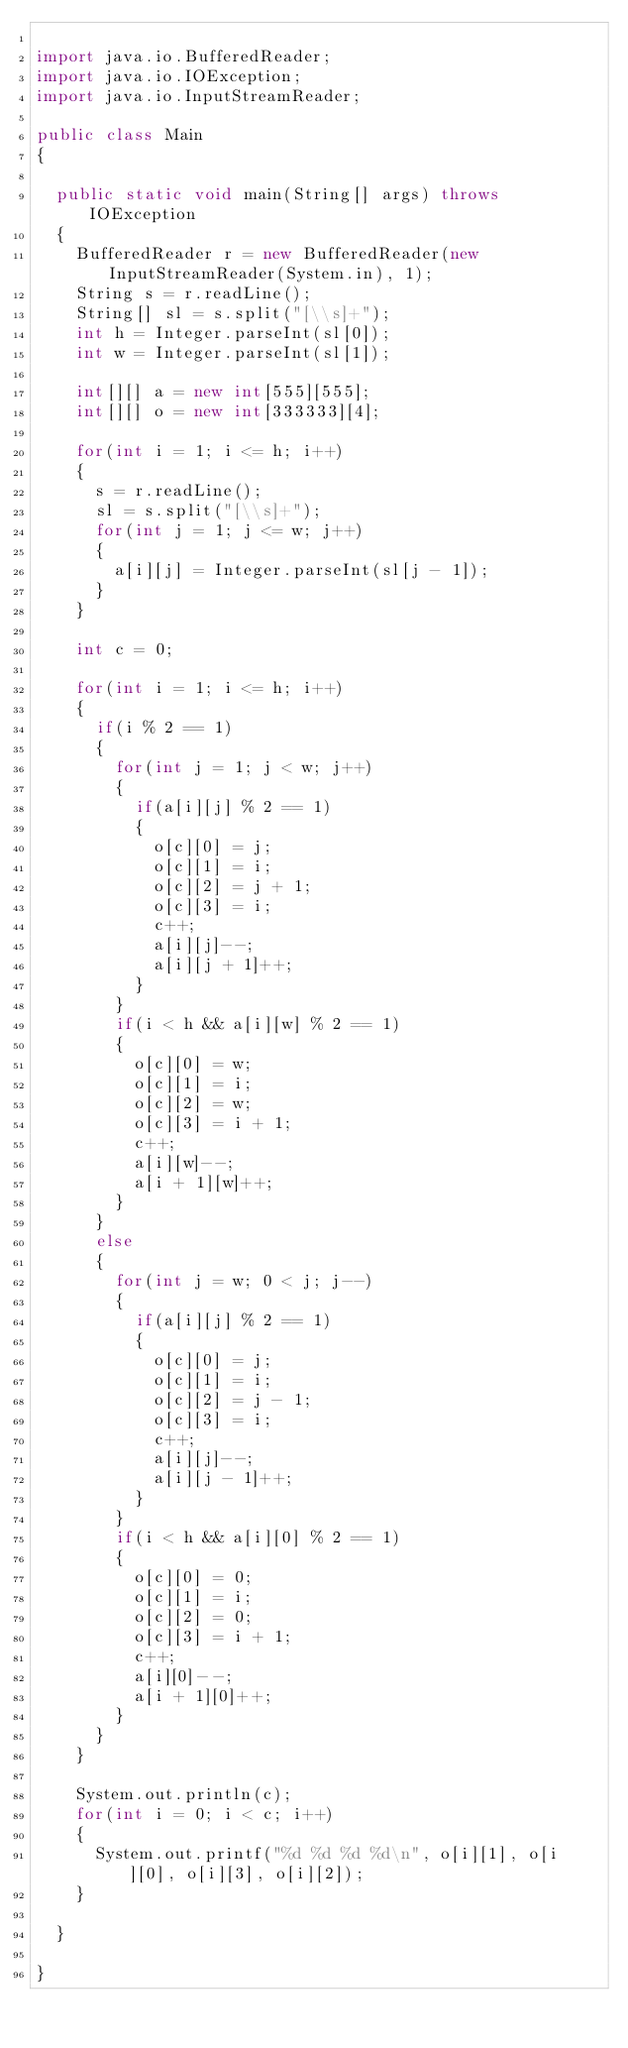<code> <loc_0><loc_0><loc_500><loc_500><_Java_>
import java.io.BufferedReader;
import java.io.IOException;
import java.io.InputStreamReader;

public class Main
{

  public static void main(String[] args) throws IOException
  {
    BufferedReader r = new BufferedReader(new InputStreamReader(System.in), 1);
    String s = r.readLine();
    String[] sl = s.split("[\\s]+");
    int h = Integer.parseInt(sl[0]);
    int w = Integer.parseInt(sl[1]);

    int[][] a = new int[555][555];
    int[][] o = new int[333333][4];
    
    for(int i = 1; i <= h; i++)
    {
      s = r.readLine();
      sl = s.split("[\\s]+");
      for(int j = 1; j <= w; j++)
      {
        a[i][j] = Integer.parseInt(sl[j - 1]);
      }
    }

    int c = 0;
    
    for(int i = 1; i <= h; i++)
    {
      if(i % 2 == 1)
      {
        for(int j = 1; j < w; j++)
        {
          if(a[i][j] % 2 == 1)
          {
            o[c][0] = j;
            o[c][1] = i;
            o[c][2] = j + 1;
            o[c][3] = i;
            c++;
            a[i][j]--;
            a[i][j + 1]++;
          }
        }
        if(i < h && a[i][w] % 2 == 1)
        {
          o[c][0] = w;
          o[c][1] = i;
          o[c][2] = w;
          o[c][3] = i + 1;
          c++;
          a[i][w]--;
          a[i + 1][w]++;
        }
      }
      else
      {
        for(int j = w; 0 < j; j--)
        {
          if(a[i][j] % 2 == 1)
          {
            o[c][0] = j;
            o[c][1] = i;
            o[c][2] = j - 1;
            o[c][3] = i;
            c++;
            a[i][j]--;
            a[i][j - 1]++;
          }
        }
        if(i < h && a[i][0] % 2 == 1)
        {
          o[c][0] = 0;
          o[c][1] = i;
          o[c][2] = 0;
          o[c][3] = i + 1;
          c++;
          a[i][0]--;
          a[i + 1][0]++;
        }
      }
    }
    
    System.out.println(c);
    for(int i = 0; i < c; i++)
    {
      System.out.printf("%d %d %d %d\n", o[i][1], o[i][0], o[i][3], o[i][2]);
    }

  }

}
</code> 